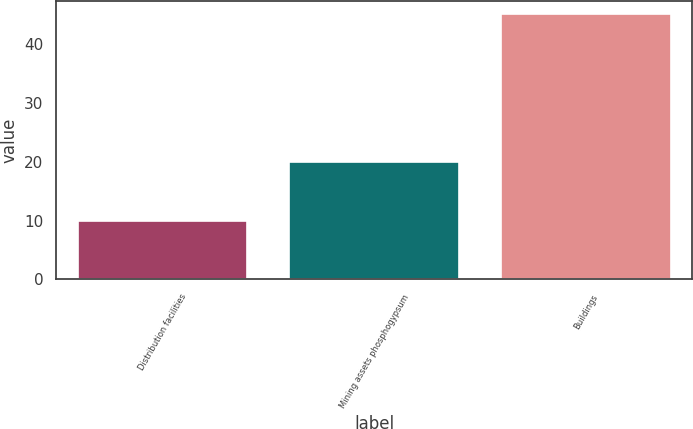Convert chart. <chart><loc_0><loc_0><loc_500><loc_500><bar_chart><fcel>Distribution facilities<fcel>Mining assets phosphogypsum<fcel>Buildings<nl><fcel>10<fcel>20<fcel>45<nl></chart> 